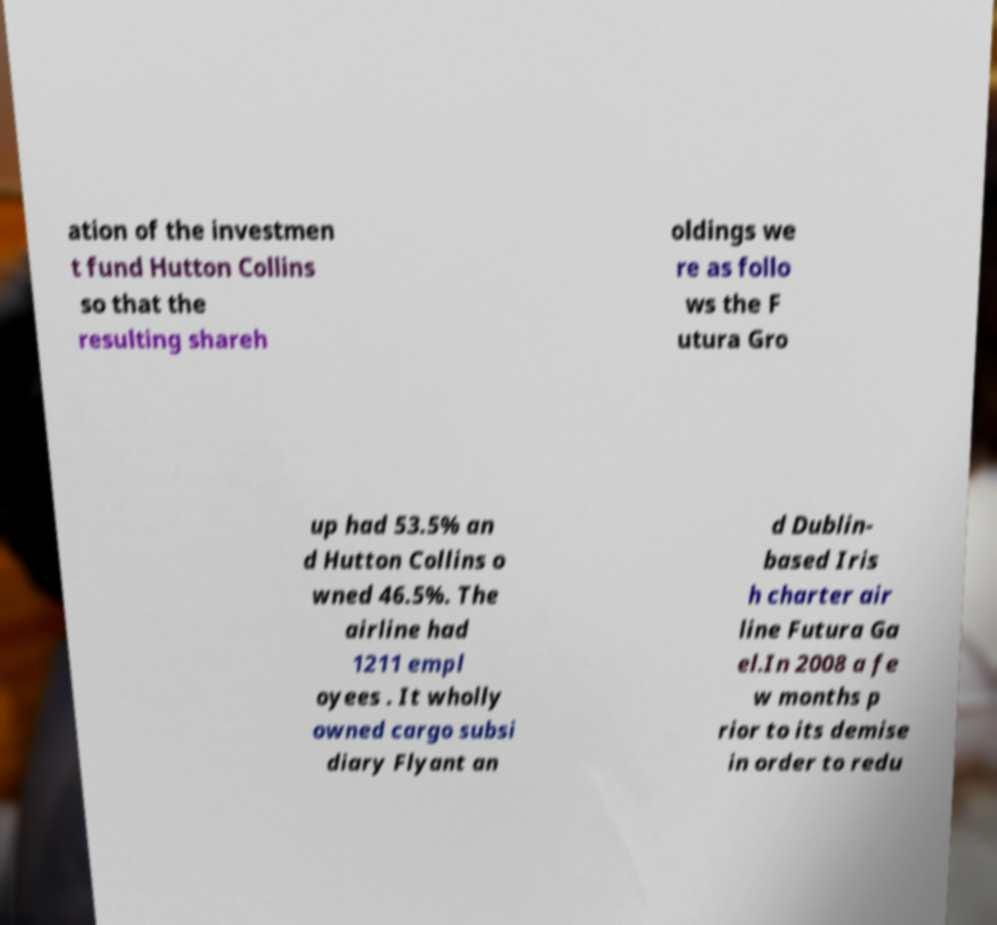Can you accurately transcribe the text from the provided image for me? ation of the investmen t fund Hutton Collins so that the resulting shareh oldings we re as follo ws the F utura Gro up had 53.5% an d Hutton Collins o wned 46.5%. The airline had 1211 empl oyees . It wholly owned cargo subsi diary Flyant an d Dublin- based Iris h charter air line Futura Ga el.In 2008 a fe w months p rior to its demise in order to redu 